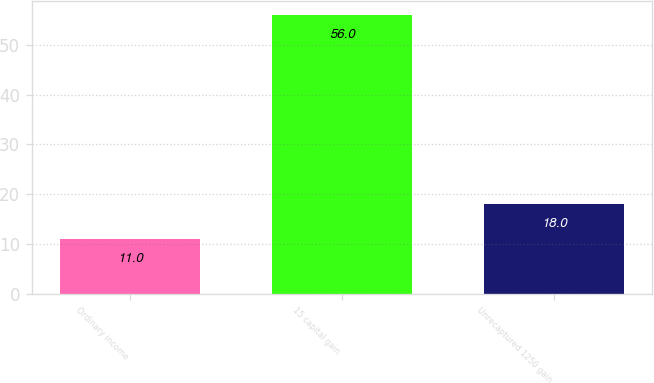<chart> <loc_0><loc_0><loc_500><loc_500><bar_chart><fcel>Ordinary income<fcel>15 capital gain<fcel>Unrecaptured 1250 gain<nl><fcel>11<fcel>56<fcel>18<nl></chart> 